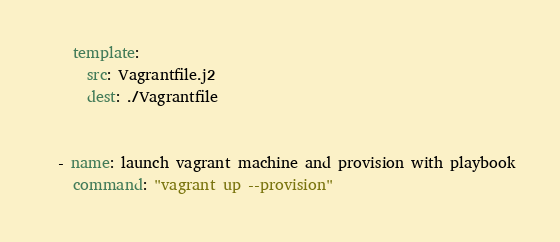<code> <loc_0><loc_0><loc_500><loc_500><_YAML_>    template:
      src: Vagrantfile.j2
      dest: ./Vagrantfile


  - name: launch vagrant machine and provision with playbook
    command: "vagrant up --provision"</code> 